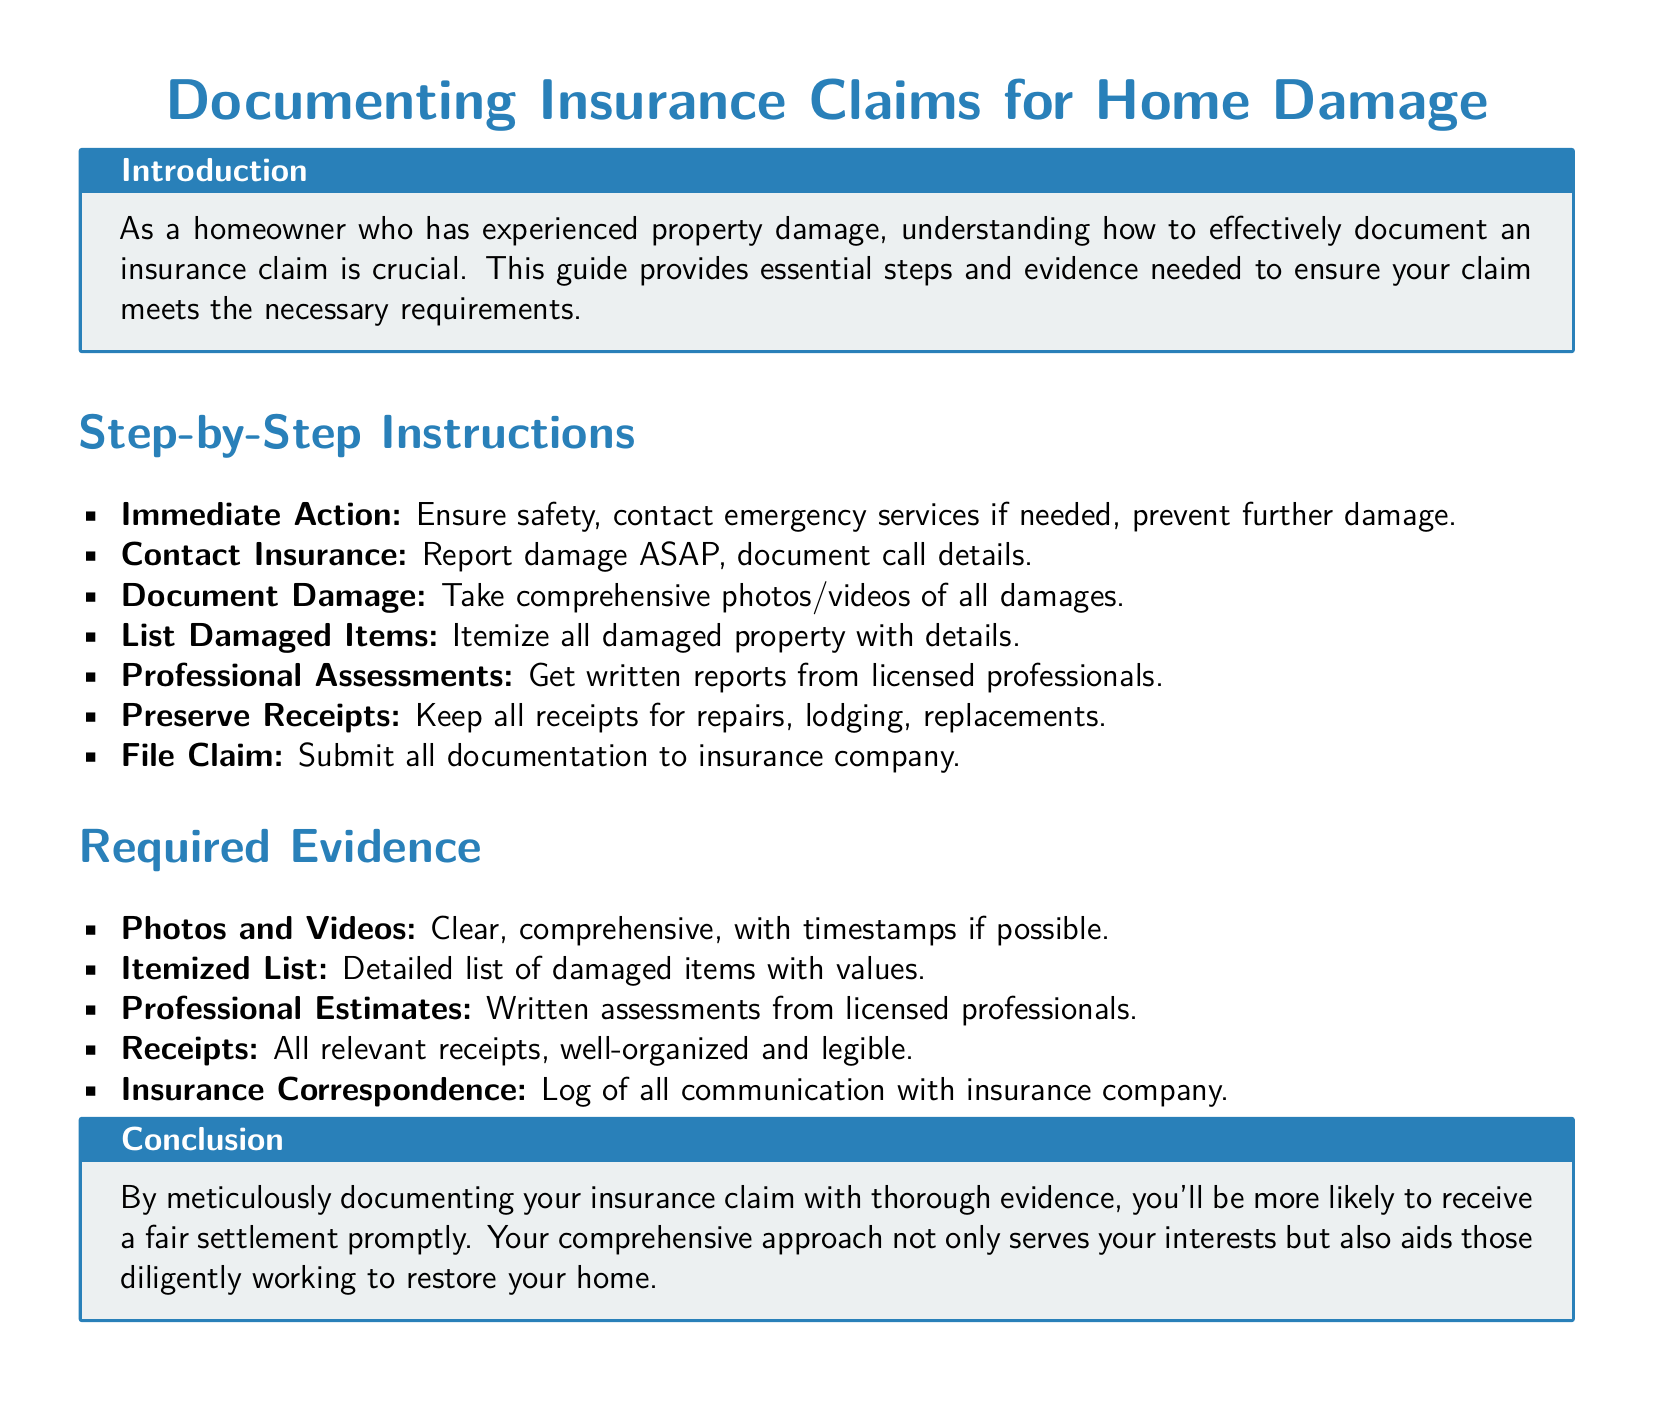What is the main purpose of the document? The main purpose of the document is to provide essential steps and evidence for effectively documenting an insurance claim for home damage.
Answer: To document insurance claims for home damage How many steps are listed for documenting an insurance claim? The document lists a total of seven steps for documenting an insurance claim.
Answer: Seven What evidence is required to support the insurance claim? The document outlines five different types of evidence that are required to support an insurance claim.
Answer: Five What should you do immediately after experiencing property damage? According to the document, the immediate action after experiencing property damage is to ensure safety and contact emergency services if needed.
Answer: Ensure safety What type of professionals should you get assessments from? The document specifies that you should get written reports from licensed professionals.
Answer: Licensed professionals What should be preserved along with receipts? The document advises preserving all receipts for repairs, lodging, and replacements along with other evidence.
Answer: All receipts What color is used for the title section in the document? The document uses a particular shade of blue identified as maincolor for the title section.
Answer: Maincolor What is the concluding message of the document? The conclusion emphasizes that careful documentation aids in receiving a fair settlement.
Answer: Fair settlement 